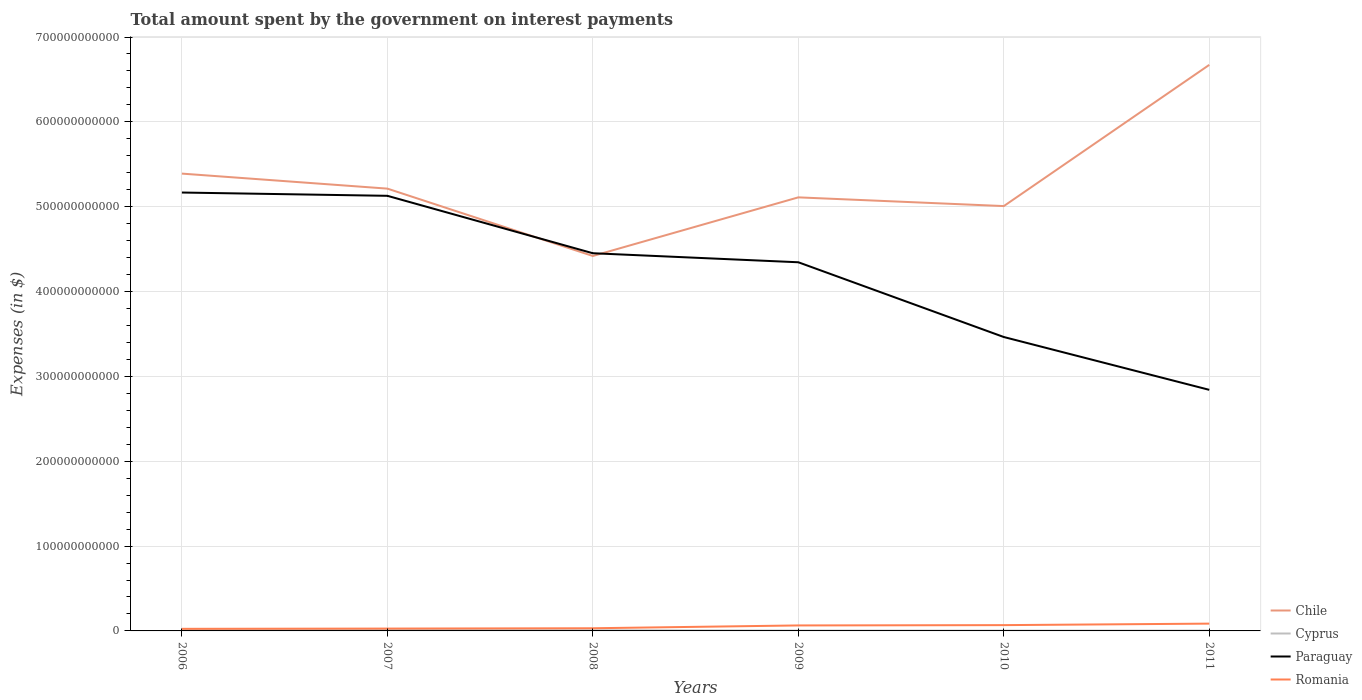How many different coloured lines are there?
Your answer should be very brief. 4. Does the line corresponding to Paraguay intersect with the line corresponding to Chile?
Ensure brevity in your answer.  Yes. Is the number of lines equal to the number of legend labels?
Your response must be concise. Yes. Across all years, what is the maximum amount spent on interest payments by the government in Paraguay?
Ensure brevity in your answer.  2.84e+11. In which year was the amount spent on interest payments by the government in Cyprus maximum?
Your answer should be very brief. 2010. What is the total amount spent on interest payments by the government in Romania in the graph?
Make the answer very short. -3.70e+09. What is the difference between the highest and the second highest amount spent on interest payments by the government in Chile?
Offer a terse response. 2.25e+11. What is the difference between the highest and the lowest amount spent on interest payments by the government in Chile?
Provide a short and direct response. 2. How many lines are there?
Ensure brevity in your answer.  4. How many years are there in the graph?
Make the answer very short. 6. What is the difference between two consecutive major ticks on the Y-axis?
Give a very brief answer. 1.00e+11. Where does the legend appear in the graph?
Your answer should be very brief. Bottom right. How are the legend labels stacked?
Your answer should be compact. Vertical. What is the title of the graph?
Provide a short and direct response. Total amount spent by the government on interest payments. What is the label or title of the X-axis?
Provide a short and direct response. Years. What is the label or title of the Y-axis?
Ensure brevity in your answer.  Expenses (in $). What is the Expenses (in $) of Chile in 2006?
Offer a terse response. 5.39e+11. What is the Expenses (in $) in Cyprus in 2006?
Ensure brevity in your answer.  1.10e+09. What is the Expenses (in $) of Paraguay in 2006?
Your answer should be very brief. 5.17e+11. What is the Expenses (in $) in Romania in 2006?
Keep it short and to the point. 2.46e+09. What is the Expenses (in $) in Chile in 2007?
Your answer should be very brief. 5.21e+11. What is the Expenses (in $) in Cyprus in 2007?
Offer a terse response. 1.14e+09. What is the Expenses (in $) in Paraguay in 2007?
Offer a terse response. 5.13e+11. What is the Expenses (in $) in Romania in 2007?
Your answer should be very brief. 2.77e+09. What is the Expenses (in $) in Chile in 2008?
Give a very brief answer. 4.42e+11. What is the Expenses (in $) of Cyprus in 2008?
Your answer should be very brief. 7.95e+08. What is the Expenses (in $) of Paraguay in 2008?
Make the answer very short. 4.45e+11. What is the Expenses (in $) of Romania in 2008?
Your answer should be very brief. 3.15e+09. What is the Expenses (in $) of Chile in 2009?
Provide a succinct answer. 5.11e+11. What is the Expenses (in $) of Cyprus in 2009?
Offer a very short reply. 4.03e+08. What is the Expenses (in $) of Paraguay in 2009?
Your answer should be very brief. 4.35e+11. What is the Expenses (in $) of Romania in 2009?
Give a very brief answer. 6.47e+09. What is the Expenses (in $) of Chile in 2010?
Your answer should be compact. 5.01e+11. What is the Expenses (in $) in Cyprus in 2010?
Your response must be concise. 3.62e+08. What is the Expenses (in $) in Paraguay in 2010?
Offer a very short reply. 3.46e+11. What is the Expenses (in $) of Romania in 2010?
Your answer should be very brief. 6.84e+09. What is the Expenses (in $) in Chile in 2011?
Your response must be concise. 6.67e+11. What is the Expenses (in $) of Cyprus in 2011?
Offer a very short reply. 3.98e+08. What is the Expenses (in $) in Paraguay in 2011?
Provide a short and direct response. 2.84e+11. What is the Expenses (in $) in Romania in 2011?
Keep it short and to the point. 8.61e+09. Across all years, what is the maximum Expenses (in $) of Chile?
Offer a very short reply. 6.67e+11. Across all years, what is the maximum Expenses (in $) of Cyprus?
Your response must be concise. 1.14e+09. Across all years, what is the maximum Expenses (in $) of Paraguay?
Make the answer very short. 5.17e+11. Across all years, what is the maximum Expenses (in $) in Romania?
Give a very brief answer. 8.61e+09. Across all years, what is the minimum Expenses (in $) in Chile?
Make the answer very short. 4.42e+11. Across all years, what is the minimum Expenses (in $) of Cyprus?
Provide a short and direct response. 3.62e+08. Across all years, what is the minimum Expenses (in $) in Paraguay?
Offer a terse response. 2.84e+11. Across all years, what is the minimum Expenses (in $) of Romania?
Your answer should be very brief. 2.46e+09. What is the total Expenses (in $) of Chile in the graph?
Ensure brevity in your answer.  3.18e+12. What is the total Expenses (in $) of Cyprus in the graph?
Provide a succinct answer. 4.20e+09. What is the total Expenses (in $) of Paraguay in the graph?
Provide a succinct answer. 2.54e+12. What is the total Expenses (in $) of Romania in the graph?
Offer a terse response. 3.03e+1. What is the difference between the Expenses (in $) of Chile in 2006 and that in 2007?
Keep it short and to the point. 1.77e+1. What is the difference between the Expenses (in $) of Cyprus in 2006 and that in 2007?
Offer a very short reply. -3.98e+07. What is the difference between the Expenses (in $) of Paraguay in 2006 and that in 2007?
Provide a succinct answer. 3.87e+09. What is the difference between the Expenses (in $) in Romania in 2006 and that in 2007?
Keep it short and to the point. -3.09e+08. What is the difference between the Expenses (in $) in Chile in 2006 and that in 2008?
Provide a short and direct response. 9.71e+1. What is the difference between the Expenses (in $) of Cyprus in 2006 and that in 2008?
Make the answer very short. 3.07e+08. What is the difference between the Expenses (in $) of Paraguay in 2006 and that in 2008?
Provide a short and direct response. 7.16e+1. What is the difference between the Expenses (in $) in Romania in 2006 and that in 2008?
Your answer should be compact. -6.95e+08. What is the difference between the Expenses (in $) of Chile in 2006 and that in 2009?
Provide a succinct answer. 2.80e+1. What is the difference between the Expenses (in $) in Cyprus in 2006 and that in 2009?
Provide a short and direct response. 6.99e+08. What is the difference between the Expenses (in $) in Paraguay in 2006 and that in 2009?
Ensure brevity in your answer.  8.22e+1. What is the difference between the Expenses (in $) in Romania in 2006 and that in 2009?
Ensure brevity in your answer.  -4.01e+09. What is the difference between the Expenses (in $) of Chile in 2006 and that in 2010?
Keep it short and to the point. 3.83e+1. What is the difference between the Expenses (in $) of Cyprus in 2006 and that in 2010?
Give a very brief answer. 7.41e+08. What is the difference between the Expenses (in $) of Paraguay in 2006 and that in 2010?
Your response must be concise. 1.70e+11. What is the difference between the Expenses (in $) of Romania in 2006 and that in 2010?
Offer a very short reply. -4.38e+09. What is the difference between the Expenses (in $) of Chile in 2006 and that in 2011?
Provide a succinct answer. -1.28e+11. What is the difference between the Expenses (in $) of Cyprus in 2006 and that in 2011?
Make the answer very short. 7.04e+08. What is the difference between the Expenses (in $) in Paraguay in 2006 and that in 2011?
Offer a terse response. 2.33e+11. What is the difference between the Expenses (in $) in Romania in 2006 and that in 2011?
Make the answer very short. -6.15e+09. What is the difference between the Expenses (in $) of Chile in 2007 and that in 2008?
Offer a terse response. 7.94e+1. What is the difference between the Expenses (in $) in Cyprus in 2007 and that in 2008?
Make the answer very short. 3.47e+08. What is the difference between the Expenses (in $) of Paraguay in 2007 and that in 2008?
Ensure brevity in your answer.  6.77e+1. What is the difference between the Expenses (in $) in Romania in 2007 and that in 2008?
Your answer should be very brief. -3.86e+08. What is the difference between the Expenses (in $) of Chile in 2007 and that in 2009?
Provide a succinct answer. 1.03e+1. What is the difference between the Expenses (in $) of Cyprus in 2007 and that in 2009?
Make the answer very short. 7.39e+08. What is the difference between the Expenses (in $) in Paraguay in 2007 and that in 2009?
Your response must be concise. 7.83e+1. What is the difference between the Expenses (in $) in Romania in 2007 and that in 2009?
Ensure brevity in your answer.  -3.70e+09. What is the difference between the Expenses (in $) in Chile in 2007 and that in 2010?
Your answer should be very brief. 2.06e+1. What is the difference between the Expenses (in $) in Cyprus in 2007 and that in 2010?
Keep it short and to the point. 7.80e+08. What is the difference between the Expenses (in $) in Paraguay in 2007 and that in 2010?
Keep it short and to the point. 1.66e+11. What is the difference between the Expenses (in $) in Romania in 2007 and that in 2010?
Provide a succinct answer. -4.07e+09. What is the difference between the Expenses (in $) of Chile in 2007 and that in 2011?
Provide a short and direct response. -1.46e+11. What is the difference between the Expenses (in $) of Cyprus in 2007 and that in 2011?
Your answer should be compact. 7.44e+08. What is the difference between the Expenses (in $) in Paraguay in 2007 and that in 2011?
Keep it short and to the point. 2.29e+11. What is the difference between the Expenses (in $) of Romania in 2007 and that in 2011?
Your answer should be very brief. -5.84e+09. What is the difference between the Expenses (in $) in Chile in 2008 and that in 2009?
Your response must be concise. -6.91e+1. What is the difference between the Expenses (in $) in Cyprus in 2008 and that in 2009?
Your response must be concise. 3.92e+08. What is the difference between the Expenses (in $) in Paraguay in 2008 and that in 2009?
Provide a short and direct response. 1.06e+1. What is the difference between the Expenses (in $) in Romania in 2008 and that in 2009?
Make the answer very short. -3.31e+09. What is the difference between the Expenses (in $) in Chile in 2008 and that in 2010?
Provide a succinct answer. -5.88e+1. What is the difference between the Expenses (in $) of Cyprus in 2008 and that in 2010?
Make the answer very short. 4.34e+08. What is the difference between the Expenses (in $) in Paraguay in 2008 and that in 2010?
Keep it short and to the point. 9.87e+1. What is the difference between the Expenses (in $) of Romania in 2008 and that in 2010?
Make the answer very short. -3.68e+09. What is the difference between the Expenses (in $) in Chile in 2008 and that in 2011?
Keep it short and to the point. -2.25e+11. What is the difference between the Expenses (in $) in Cyprus in 2008 and that in 2011?
Keep it short and to the point. 3.97e+08. What is the difference between the Expenses (in $) of Paraguay in 2008 and that in 2011?
Offer a terse response. 1.61e+11. What is the difference between the Expenses (in $) in Romania in 2008 and that in 2011?
Ensure brevity in your answer.  -5.45e+09. What is the difference between the Expenses (in $) in Chile in 2009 and that in 2010?
Your answer should be very brief. 1.03e+1. What is the difference between the Expenses (in $) in Cyprus in 2009 and that in 2010?
Provide a succinct answer. 4.11e+07. What is the difference between the Expenses (in $) of Paraguay in 2009 and that in 2010?
Give a very brief answer. 8.81e+1. What is the difference between the Expenses (in $) in Romania in 2009 and that in 2010?
Provide a short and direct response. -3.67e+08. What is the difference between the Expenses (in $) in Chile in 2009 and that in 2011?
Your answer should be compact. -1.56e+11. What is the difference between the Expenses (in $) in Cyprus in 2009 and that in 2011?
Provide a short and direct response. 4.60e+06. What is the difference between the Expenses (in $) of Paraguay in 2009 and that in 2011?
Make the answer very short. 1.50e+11. What is the difference between the Expenses (in $) of Romania in 2009 and that in 2011?
Offer a terse response. -2.14e+09. What is the difference between the Expenses (in $) of Chile in 2010 and that in 2011?
Your answer should be very brief. -1.66e+11. What is the difference between the Expenses (in $) of Cyprus in 2010 and that in 2011?
Your response must be concise. -3.65e+07. What is the difference between the Expenses (in $) of Paraguay in 2010 and that in 2011?
Offer a very short reply. 6.23e+1. What is the difference between the Expenses (in $) of Romania in 2010 and that in 2011?
Offer a very short reply. -1.77e+09. What is the difference between the Expenses (in $) in Chile in 2006 and the Expenses (in $) in Cyprus in 2007?
Provide a succinct answer. 5.38e+11. What is the difference between the Expenses (in $) of Chile in 2006 and the Expenses (in $) of Paraguay in 2007?
Ensure brevity in your answer.  2.62e+1. What is the difference between the Expenses (in $) of Chile in 2006 and the Expenses (in $) of Romania in 2007?
Make the answer very short. 5.36e+11. What is the difference between the Expenses (in $) of Cyprus in 2006 and the Expenses (in $) of Paraguay in 2007?
Your answer should be compact. -5.12e+11. What is the difference between the Expenses (in $) in Cyprus in 2006 and the Expenses (in $) in Romania in 2007?
Offer a terse response. -1.67e+09. What is the difference between the Expenses (in $) of Paraguay in 2006 and the Expenses (in $) of Romania in 2007?
Keep it short and to the point. 5.14e+11. What is the difference between the Expenses (in $) of Chile in 2006 and the Expenses (in $) of Cyprus in 2008?
Offer a very short reply. 5.38e+11. What is the difference between the Expenses (in $) of Chile in 2006 and the Expenses (in $) of Paraguay in 2008?
Ensure brevity in your answer.  9.39e+1. What is the difference between the Expenses (in $) of Chile in 2006 and the Expenses (in $) of Romania in 2008?
Make the answer very short. 5.36e+11. What is the difference between the Expenses (in $) of Cyprus in 2006 and the Expenses (in $) of Paraguay in 2008?
Your answer should be very brief. -4.44e+11. What is the difference between the Expenses (in $) of Cyprus in 2006 and the Expenses (in $) of Romania in 2008?
Offer a very short reply. -2.05e+09. What is the difference between the Expenses (in $) of Paraguay in 2006 and the Expenses (in $) of Romania in 2008?
Give a very brief answer. 5.14e+11. What is the difference between the Expenses (in $) of Chile in 2006 and the Expenses (in $) of Cyprus in 2009?
Your answer should be compact. 5.39e+11. What is the difference between the Expenses (in $) of Chile in 2006 and the Expenses (in $) of Paraguay in 2009?
Offer a terse response. 1.04e+11. What is the difference between the Expenses (in $) of Chile in 2006 and the Expenses (in $) of Romania in 2009?
Give a very brief answer. 5.33e+11. What is the difference between the Expenses (in $) in Cyprus in 2006 and the Expenses (in $) in Paraguay in 2009?
Offer a very short reply. -4.33e+11. What is the difference between the Expenses (in $) of Cyprus in 2006 and the Expenses (in $) of Romania in 2009?
Provide a short and direct response. -5.37e+09. What is the difference between the Expenses (in $) of Paraguay in 2006 and the Expenses (in $) of Romania in 2009?
Your answer should be very brief. 5.10e+11. What is the difference between the Expenses (in $) in Chile in 2006 and the Expenses (in $) in Cyprus in 2010?
Your response must be concise. 5.39e+11. What is the difference between the Expenses (in $) of Chile in 2006 and the Expenses (in $) of Paraguay in 2010?
Offer a very short reply. 1.93e+11. What is the difference between the Expenses (in $) in Chile in 2006 and the Expenses (in $) in Romania in 2010?
Ensure brevity in your answer.  5.32e+11. What is the difference between the Expenses (in $) of Cyprus in 2006 and the Expenses (in $) of Paraguay in 2010?
Your response must be concise. -3.45e+11. What is the difference between the Expenses (in $) of Cyprus in 2006 and the Expenses (in $) of Romania in 2010?
Your response must be concise. -5.73e+09. What is the difference between the Expenses (in $) in Paraguay in 2006 and the Expenses (in $) in Romania in 2010?
Provide a short and direct response. 5.10e+11. What is the difference between the Expenses (in $) in Chile in 2006 and the Expenses (in $) in Cyprus in 2011?
Ensure brevity in your answer.  5.39e+11. What is the difference between the Expenses (in $) of Chile in 2006 and the Expenses (in $) of Paraguay in 2011?
Your answer should be very brief. 2.55e+11. What is the difference between the Expenses (in $) of Chile in 2006 and the Expenses (in $) of Romania in 2011?
Ensure brevity in your answer.  5.30e+11. What is the difference between the Expenses (in $) of Cyprus in 2006 and the Expenses (in $) of Paraguay in 2011?
Offer a very short reply. -2.83e+11. What is the difference between the Expenses (in $) of Cyprus in 2006 and the Expenses (in $) of Romania in 2011?
Provide a succinct answer. -7.51e+09. What is the difference between the Expenses (in $) in Paraguay in 2006 and the Expenses (in $) in Romania in 2011?
Ensure brevity in your answer.  5.08e+11. What is the difference between the Expenses (in $) in Chile in 2007 and the Expenses (in $) in Cyprus in 2008?
Provide a succinct answer. 5.21e+11. What is the difference between the Expenses (in $) in Chile in 2007 and the Expenses (in $) in Paraguay in 2008?
Your answer should be compact. 7.62e+1. What is the difference between the Expenses (in $) of Chile in 2007 and the Expenses (in $) of Romania in 2008?
Your answer should be very brief. 5.18e+11. What is the difference between the Expenses (in $) of Cyprus in 2007 and the Expenses (in $) of Paraguay in 2008?
Provide a succinct answer. -4.44e+11. What is the difference between the Expenses (in $) of Cyprus in 2007 and the Expenses (in $) of Romania in 2008?
Provide a succinct answer. -2.01e+09. What is the difference between the Expenses (in $) of Paraguay in 2007 and the Expenses (in $) of Romania in 2008?
Provide a succinct answer. 5.10e+11. What is the difference between the Expenses (in $) in Chile in 2007 and the Expenses (in $) in Cyprus in 2009?
Offer a very short reply. 5.21e+11. What is the difference between the Expenses (in $) in Chile in 2007 and the Expenses (in $) in Paraguay in 2009?
Your answer should be very brief. 8.68e+1. What is the difference between the Expenses (in $) in Chile in 2007 and the Expenses (in $) in Romania in 2009?
Provide a succinct answer. 5.15e+11. What is the difference between the Expenses (in $) in Cyprus in 2007 and the Expenses (in $) in Paraguay in 2009?
Make the answer very short. -4.33e+11. What is the difference between the Expenses (in $) in Cyprus in 2007 and the Expenses (in $) in Romania in 2009?
Provide a succinct answer. -5.33e+09. What is the difference between the Expenses (in $) of Paraguay in 2007 and the Expenses (in $) of Romania in 2009?
Make the answer very short. 5.06e+11. What is the difference between the Expenses (in $) of Chile in 2007 and the Expenses (in $) of Cyprus in 2010?
Make the answer very short. 5.21e+11. What is the difference between the Expenses (in $) of Chile in 2007 and the Expenses (in $) of Paraguay in 2010?
Offer a terse response. 1.75e+11. What is the difference between the Expenses (in $) in Chile in 2007 and the Expenses (in $) in Romania in 2010?
Provide a succinct answer. 5.14e+11. What is the difference between the Expenses (in $) of Cyprus in 2007 and the Expenses (in $) of Paraguay in 2010?
Your response must be concise. -3.45e+11. What is the difference between the Expenses (in $) of Cyprus in 2007 and the Expenses (in $) of Romania in 2010?
Provide a short and direct response. -5.69e+09. What is the difference between the Expenses (in $) in Paraguay in 2007 and the Expenses (in $) in Romania in 2010?
Give a very brief answer. 5.06e+11. What is the difference between the Expenses (in $) of Chile in 2007 and the Expenses (in $) of Cyprus in 2011?
Your answer should be very brief. 5.21e+11. What is the difference between the Expenses (in $) of Chile in 2007 and the Expenses (in $) of Paraguay in 2011?
Ensure brevity in your answer.  2.37e+11. What is the difference between the Expenses (in $) of Chile in 2007 and the Expenses (in $) of Romania in 2011?
Keep it short and to the point. 5.13e+11. What is the difference between the Expenses (in $) of Cyprus in 2007 and the Expenses (in $) of Paraguay in 2011?
Make the answer very short. -2.83e+11. What is the difference between the Expenses (in $) in Cyprus in 2007 and the Expenses (in $) in Romania in 2011?
Keep it short and to the point. -7.47e+09. What is the difference between the Expenses (in $) in Paraguay in 2007 and the Expenses (in $) in Romania in 2011?
Make the answer very short. 5.04e+11. What is the difference between the Expenses (in $) of Chile in 2008 and the Expenses (in $) of Cyprus in 2009?
Your answer should be very brief. 4.42e+11. What is the difference between the Expenses (in $) in Chile in 2008 and the Expenses (in $) in Paraguay in 2009?
Your answer should be very brief. 7.42e+09. What is the difference between the Expenses (in $) in Chile in 2008 and the Expenses (in $) in Romania in 2009?
Provide a succinct answer. 4.35e+11. What is the difference between the Expenses (in $) of Cyprus in 2008 and the Expenses (in $) of Paraguay in 2009?
Make the answer very short. -4.34e+11. What is the difference between the Expenses (in $) in Cyprus in 2008 and the Expenses (in $) in Romania in 2009?
Offer a terse response. -5.67e+09. What is the difference between the Expenses (in $) in Paraguay in 2008 and the Expenses (in $) in Romania in 2009?
Offer a terse response. 4.39e+11. What is the difference between the Expenses (in $) of Chile in 2008 and the Expenses (in $) of Cyprus in 2010?
Keep it short and to the point. 4.42e+11. What is the difference between the Expenses (in $) of Chile in 2008 and the Expenses (in $) of Paraguay in 2010?
Give a very brief answer. 9.55e+1. What is the difference between the Expenses (in $) of Chile in 2008 and the Expenses (in $) of Romania in 2010?
Make the answer very short. 4.35e+11. What is the difference between the Expenses (in $) of Cyprus in 2008 and the Expenses (in $) of Paraguay in 2010?
Give a very brief answer. -3.46e+11. What is the difference between the Expenses (in $) in Cyprus in 2008 and the Expenses (in $) in Romania in 2010?
Keep it short and to the point. -6.04e+09. What is the difference between the Expenses (in $) of Paraguay in 2008 and the Expenses (in $) of Romania in 2010?
Offer a very short reply. 4.38e+11. What is the difference between the Expenses (in $) in Chile in 2008 and the Expenses (in $) in Cyprus in 2011?
Your answer should be compact. 4.42e+11. What is the difference between the Expenses (in $) of Chile in 2008 and the Expenses (in $) of Paraguay in 2011?
Ensure brevity in your answer.  1.58e+11. What is the difference between the Expenses (in $) in Chile in 2008 and the Expenses (in $) in Romania in 2011?
Your answer should be compact. 4.33e+11. What is the difference between the Expenses (in $) in Cyprus in 2008 and the Expenses (in $) in Paraguay in 2011?
Make the answer very short. -2.83e+11. What is the difference between the Expenses (in $) in Cyprus in 2008 and the Expenses (in $) in Romania in 2011?
Keep it short and to the point. -7.81e+09. What is the difference between the Expenses (in $) in Paraguay in 2008 and the Expenses (in $) in Romania in 2011?
Offer a very short reply. 4.37e+11. What is the difference between the Expenses (in $) in Chile in 2009 and the Expenses (in $) in Cyprus in 2010?
Keep it short and to the point. 5.11e+11. What is the difference between the Expenses (in $) of Chile in 2009 and the Expenses (in $) of Paraguay in 2010?
Your response must be concise. 1.65e+11. What is the difference between the Expenses (in $) of Chile in 2009 and the Expenses (in $) of Romania in 2010?
Your answer should be compact. 5.04e+11. What is the difference between the Expenses (in $) of Cyprus in 2009 and the Expenses (in $) of Paraguay in 2010?
Provide a succinct answer. -3.46e+11. What is the difference between the Expenses (in $) of Cyprus in 2009 and the Expenses (in $) of Romania in 2010?
Provide a short and direct response. -6.43e+09. What is the difference between the Expenses (in $) of Paraguay in 2009 and the Expenses (in $) of Romania in 2010?
Offer a terse response. 4.28e+11. What is the difference between the Expenses (in $) of Chile in 2009 and the Expenses (in $) of Cyprus in 2011?
Keep it short and to the point. 5.11e+11. What is the difference between the Expenses (in $) in Chile in 2009 and the Expenses (in $) in Paraguay in 2011?
Keep it short and to the point. 2.27e+11. What is the difference between the Expenses (in $) of Chile in 2009 and the Expenses (in $) of Romania in 2011?
Keep it short and to the point. 5.02e+11. What is the difference between the Expenses (in $) in Cyprus in 2009 and the Expenses (in $) in Paraguay in 2011?
Your answer should be very brief. -2.84e+11. What is the difference between the Expenses (in $) in Cyprus in 2009 and the Expenses (in $) in Romania in 2011?
Provide a succinct answer. -8.20e+09. What is the difference between the Expenses (in $) of Paraguay in 2009 and the Expenses (in $) of Romania in 2011?
Your response must be concise. 4.26e+11. What is the difference between the Expenses (in $) in Chile in 2010 and the Expenses (in $) in Cyprus in 2011?
Give a very brief answer. 5.00e+11. What is the difference between the Expenses (in $) in Chile in 2010 and the Expenses (in $) in Paraguay in 2011?
Your response must be concise. 2.17e+11. What is the difference between the Expenses (in $) of Chile in 2010 and the Expenses (in $) of Romania in 2011?
Offer a terse response. 4.92e+11. What is the difference between the Expenses (in $) of Cyprus in 2010 and the Expenses (in $) of Paraguay in 2011?
Ensure brevity in your answer.  -2.84e+11. What is the difference between the Expenses (in $) of Cyprus in 2010 and the Expenses (in $) of Romania in 2011?
Give a very brief answer. -8.25e+09. What is the difference between the Expenses (in $) of Paraguay in 2010 and the Expenses (in $) of Romania in 2011?
Your answer should be very brief. 3.38e+11. What is the average Expenses (in $) in Chile per year?
Offer a terse response. 5.30e+11. What is the average Expenses (in $) of Cyprus per year?
Offer a terse response. 7.00e+08. What is the average Expenses (in $) in Paraguay per year?
Make the answer very short. 4.23e+11. What is the average Expenses (in $) in Romania per year?
Provide a succinct answer. 5.05e+09. In the year 2006, what is the difference between the Expenses (in $) in Chile and Expenses (in $) in Cyprus?
Provide a short and direct response. 5.38e+11. In the year 2006, what is the difference between the Expenses (in $) in Chile and Expenses (in $) in Paraguay?
Give a very brief answer. 2.23e+1. In the year 2006, what is the difference between the Expenses (in $) in Chile and Expenses (in $) in Romania?
Your answer should be very brief. 5.37e+11. In the year 2006, what is the difference between the Expenses (in $) of Cyprus and Expenses (in $) of Paraguay?
Your response must be concise. -5.16e+11. In the year 2006, what is the difference between the Expenses (in $) in Cyprus and Expenses (in $) in Romania?
Offer a terse response. -1.36e+09. In the year 2006, what is the difference between the Expenses (in $) of Paraguay and Expenses (in $) of Romania?
Make the answer very short. 5.14e+11. In the year 2007, what is the difference between the Expenses (in $) of Chile and Expenses (in $) of Cyprus?
Your answer should be very brief. 5.20e+11. In the year 2007, what is the difference between the Expenses (in $) in Chile and Expenses (in $) in Paraguay?
Your answer should be very brief. 8.47e+09. In the year 2007, what is the difference between the Expenses (in $) of Chile and Expenses (in $) of Romania?
Keep it short and to the point. 5.19e+11. In the year 2007, what is the difference between the Expenses (in $) of Cyprus and Expenses (in $) of Paraguay?
Give a very brief answer. -5.12e+11. In the year 2007, what is the difference between the Expenses (in $) of Cyprus and Expenses (in $) of Romania?
Give a very brief answer. -1.63e+09. In the year 2007, what is the difference between the Expenses (in $) in Paraguay and Expenses (in $) in Romania?
Keep it short and to the point. 5.10e+11. In the year 2008, what is the difference between the Expenses (in $) of Chile and Expenses (in $) of Cyprus?
Offer a very short reply. 4.41e+11. In the year 2008, what is the difference between the Expenses (in $) of Chile and Expenses (in $) of Paraguay?
Provide a short and direct response. -3.22e+09. In the year 2008, what is the difference between the Expenses (in $) of Chile and Expenses (in $) of Romania?
Your answer should be compact. 4.39e+11. In the year 2008, what is the difference between the Expenses (in $) of Cyprus and Expenses (in $) of Paraguay?
Make the answer very short. -4.44e+11. In the year 2008, what is the difference between the Expenses (in $) in Cyprus and Expenses (in $) in Romania?
Make the answer very short. -2.36e+09. In the year 2008, what is the difference between the Expenses (in $) in Paraguay and Expenses (in $) in Romania?
Make the answer very short. 4.42e+11. In the year 2009, what is the difference between the Expenses (in $) of Chile and Expenses (in $) of Cyprus?
Keep it short and to the point. 5.11e+11. In the year 2009, what is the difference between the Expenses (in $) in Chile and Expenses (in $) in Paraguay?
Keep it short and to the point. 7.65e+1. In the year 2009, what is the difference between the Expenses (in $) in Chile and Expenses (in $) in Romania?
Your answer should be compact. 5.05e+11. In the year 2009, what is the difference between the Expenses (in $) in Cyprus and Expenses (in $) in Paraguay?
Give a very brief answer. -4.34e+11. In the year 2009, what is the difference between the Expenses (in $) in Cyprus and Expenses (in $) in Romania?
Give a very brief answer. -6.07e+09. In the year 2009, what is the difference between the Expenses (in $) of Paraguay and Expenses (in $) of Romania?
Your response must be concise. 4.28e+11. In the year 2010, what is the difference between the Expenses (in $) in Chile and Expenses (in $) in Cyprus?
Provide a succinct answer. 5.00e+11. In the year 2010, what is the difference between the Expenses (in $) of Chile and Expenses (in $) of Paraguay?
Keep it short and to the point. 1.54e+11. In the year 2010, what is the difference between the Expenses (in $) of Chile and Expenses (in $) of Romania?
Your response must be concise. 4.94e+11. In the year 2010, what is the difference between the Expenses (in $) in Cyprus and Expenses (in $) in Paraguay?
Give a very brief answer. -3.46e+11. In the year 2010, what is the difference between the Expenses (in $) of Cyprus and Expenses (in $) of Romania?
Your answer should be very brief. -6.47e+09. In the year 2010, what is the difference between the Expenses (in $) in Paraguay and Expenses (in $) in Romania?
Keep it short and to the point. 3.40e+11. In the year 2011, what is the difference between the Expenses (in $) in Chile and Expenses (in $) in Cyprus?
Your response must be concise. 6.67e+11. In the year 2011, what is the difference between the Expenses (in $) of Chile and Expenses (in $) of Paraguay?
Offer a terse response. 3.83e+11. In the year 2011, what is the difference between the Expenses (in $) of Chile and Expenses (in $) of Romania?
Provide a succinct answer. 6.59e+11. In the year 2011, what is the difference between the Expenses (in $) of Cyprus and Expenses (in $) of Paraguay?
Offer a very short reply. -2.84e+11. In the year 2011, what is the difference between the Expenses (in $) in Cyprus and Expenses (in $) in Romania?
Keep it short and to the point. -8.21e+09. In the year 2011, what is the difference between the Expenses (in $) of Paraguay and Expenses (in $) of Romania?
Your response must be concise. 2.76e+11. What is the ratio of the Expenses (in $) in Chile in 2006 to that in 2007?
Ensure brevity in your answer.  1.03. What is the ratio of the Expenses (in $) of Cyprus in 2006 to that in 2007?
Ensure brevity in your answer.  0.97. What is the ratio of the Expenses (in $) of Paraguay in 2006 to that in 2007?
Provide a succinct answer. 1.01. What is the ratio of the Expenses (in $) in Romania in 2006 to that in 2007?
Provide a short and direct response. 0.89. What is the ratio of the Expenses (in $) in Chile in 2006 to that in 2008?
Your answer should be compact. 1.22. What is the ratio of the Expenses (in $) in Cyprus in 2006 to that in 2008?
Your answer should be very brief. 1.39. What is the ratio of the Expenses (in $) in Paraguay in 2006 to that in 2008?
Ensure brevity in your answer.  1.16. What is the ratio of the Expenses (in $) in Romania in 2006 to that in 2008?
Give a very brief answer. 0.78. What is the ratio of the Expenses (in $) in Chile in 2006 to that in 2009?
Your answer should be compact. 1.05. What is the ratio of the Expenses (in $) of Cyprus in 2006 to that in 2009?
Your answer should be very brief. 2.74. What is the ratio of the Expenses (in $) of Paraguay in 2006 to that in 2009?
Your answer should be very brief. 1.19. What is the ratio of the Expenses (in $) in Romania in 2006 to that in 2009?
Keep it short and to the point. 0.38. What is the ratio of the Expenses (in $) in Chile in 2006 to that in 2010?
Give a very brief answer. 1.08. What is the ratio of the Expenses (in $) in Cyprus in 2006 to that in 2010?
Offer a very short reply. 3.05. What is the ratio of the Expenses (in $) in Paraguay in 2006 to that in 2010?
Give a very brief answer. 1.49. What is the ratio of the Expenses (in $) in Romania in 2006 to that in 2010?
Provide a short and direct response. 0.36. What is the ratio of the Expenses (in $) in Chile in 2006 to that in 2011?
Offer a terse response. 0.81. What is the ratio of the Expenses (in $) of Cyprus in 2006 to that in 2011?
Your response must be concise. 2.77. What is the ratio of the Expenses (in $) of Paraguay in 2006 to that in 2011?
Make the answer very short. 1.82. What is the ratio of the Expenses (in $) in Romania in 2006 to that in 2011?
Provide a short and direct response. 0.29. What is the ratio of the Expenses (in $) in Chile in 2007 to that in 2008?
Ensure brevity in your answer.  1.18. What is the ratio of the Expenses (in $) of Cyprus in 2007 to that in 2008?
Offer a terse response. 1.44. What is the ratio of the Expenses (in $) of Paraguay in 2007 to that in 2008?
Offer a very short reply. 1.15. What is the ratio of the Expenses (in $) of Romania in 2007 to that in 2008?
Your answer should be compact. 0.88. What is the ratio of the Expenses (in $) in Chile in 2007 to that in 2009?
Ensure brevity in your answer.  1.02. What is the ratio of the Expenses (in $) in Cyprus in 2007 to that in 2009?
Provide a succinct answer. 2.84. What is the ratio of the Expenses (in $) in Paraguay in 2007 to that in 2009?
Provide a short and direct response. 1.18. What is the ratio of the Expenses (in $) in Romania in 2007 to that in 2009?
Provide a succinct answer. 0.43. What is the ratio of the Expenses (in $) of Chile in 2007 to that in 2010?
Give a very brief answer. 1.04. What is the ratio of the Expenses (in $) in Cyprus in 2007 to that in 2010?
Offer a terse response. 3.16. What is the ratio of the Expenses (in $) of Paraguay in 2007 to that in 2010?
Your response must be concise. 1.48. What is the ratio of the Expenses (in $) in Romania in 2007 to that in 2010?
Give a very brief answer. 0.41. What is the ratio of the Expenses (in $) in Chile in 2007 to that in 2011?
Your answer should be very brief. 0.78. What is the ratio of the Expenses (in $) in Cyprus in 2007 to that in 2011?
Offer a very short reply. 2.87. What is the ratio of the Expenses (in $) of Paraguay in 2007 to that in 2011?
Your answer should be very brief. 1.8. What is the ratio of the Expenses (in $) of Romania in 2007 to that in 2011?
Keep it short and to the point. 0.32. What is the ratio of the Expenses (in $) of Chile in 2008 to that in 2009?
Give a very brief answer. 0.86. What is the ratio of the Expenses (in $) in Cyprus in 2008 to that in 2009?
Give a very brief answer. 1.97. What is the ratio of the Expenses (in $) in Paraguay in 2008 to that in 2009?
Keep it short and to the point. 1.02. What is the ratio of the Expenses (in $) in Romania in 2008 to that in 2009?
Make the answer very short. 0.49. What is the ratio of the Expenses (in $) in Chile in 2008 to that in 2010?
Offer a terse response. 0.88. What is the ratio of the Expenses (in $) in Cyprus in 2008 to that in 2010?
Offer a terse response. 2.2. What is the ratio of the Expenses (in $) of Paraguay in 2008 to that in 2010?
Ensure brevity in your answer.  1.29. What is the ratio of the Expenses (in $) in Romania in 2008 to that in 2010?
Provide a short and direct response. 0.46. What is the ratio of the Expenses (in $) in Chile in 2008 to that in 2011?
Keep it short and to the point. 0.66. What is the ratio of the Expenses (in $) in Cyprus in 2008 to that in 2011?
Provide a succinct answer. 2. What is the ratio of the Expenses (in $) of Paraguay in 2008 to that in 2011?
Offer a terse response. 1.57. What is the ratio of the Expenses (in $) in Romania in 2008 to that in 2011?
Ensure brevity in your answer.  0.37. What is the ratio of the Expenses (in $) of Chile in 2009 to that in 2010?
Your answer should be very brief. 1.02. What is the ratio of the Expenses (in $) of Cyprus in 2009 to that in 2010?
Your answer should be compact. 1.11. What is the ratio of the Expenses (in $) of Paraguay in 2009 to that in 2010?
Your answer should be compact. 1.25. What is the ratio of the Expenses (in $) of Romania in 2009 to that in 2010?
Your response must be concise. 0.95. What is the ratio of the Expenses (in $) in Chile in 2009 to that in 2011?
Your answer should be very brief. 0.77. What is the ratio of the Expenses (in $) of Cyprus in 2009 to that in 2011?
Provide a succinct answer. 1.01. What is the ratio of the Expenses (in $) of Paraguay in 2009 to that in 2011?
Offer a very short reply. 1.53. What is the ratio of the Expenses (in $) of Romania in 2009 to that in 2011?
Your response must be concise. 0.75. What is the ratio of the Expenses (in $) in Chile in 2010 to that in 2011?
Your response must be concise. 0.75. What is the ratio of the Expenses (in $) in Cyprus in 2010 to that in 2011?
Offer a very short reply. 0.91. What is the ratio of the Expenses (in $) of Paraguay in 2010 to that in 2011?
Provide a succinct answer. 1.22. What is the ratio of the Expenses (in $) in Romania in 2010 to that in 2011?
Your response must be concise. 0.79. What is the difference between the highest and the second highest Expenses (in $) in Chile?
Ensure brevity in your answer.  1.28e+11. What is the difference between the highest and the second highest Expenses (in $) in Cyprus?
Ensure brevity in your answer.  3.98e+07. What is the difference between the highest and the second highest Expenses (in $) of Paraguay?
Offer a terse response. 3.87e+09. What is the difference between the highest and the second highest Expenses (in $) in Romania?
Offer a terse response. 1.77e+09. What is the difference between the highest and the lowest Expenses (in $) in Chile?
Provide a succinct answer. 2.25e+11. What is the difference between the highest and the lowest Expenses (in $) in Cyprus?
Ensure brevity in your answer.  7.80e+08. What is the difference between the highest and the lowest Expenses (in $) of Paraguay?
Your answer should be very brief. 2.33e+11. What is the difference between the highest and the lowest Expenses (in $) in Romania?
Ensure brevity in your answer.  6.15e+09. 